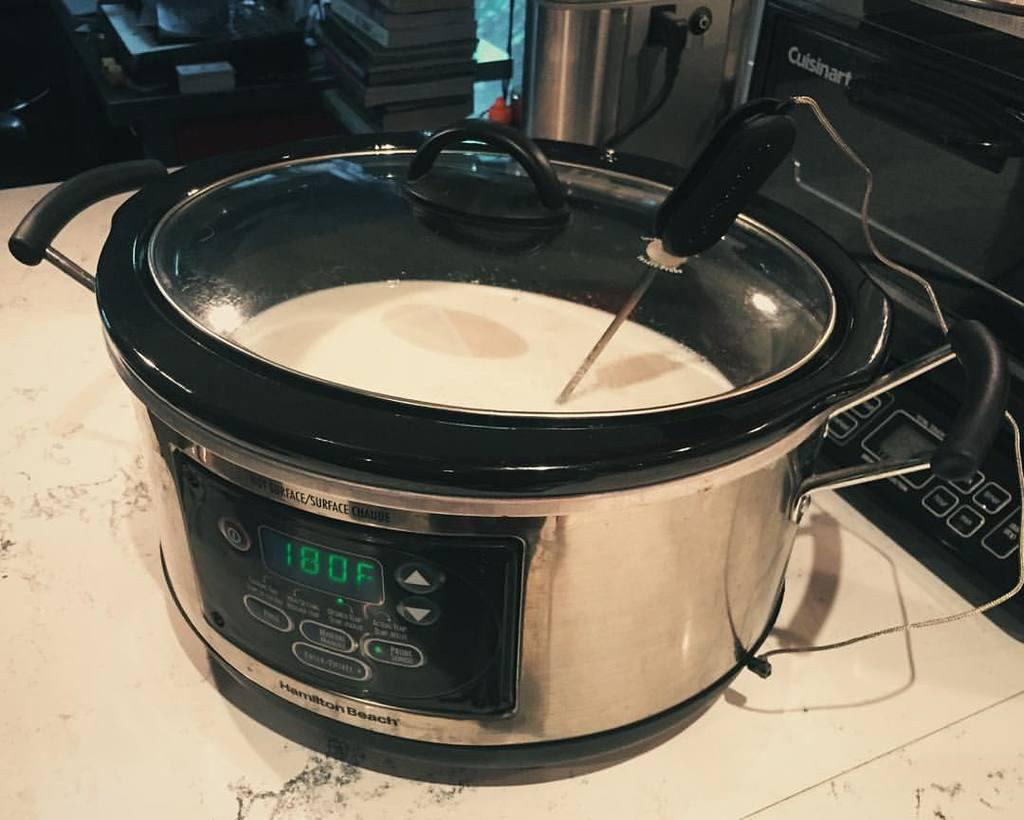Provide a one-sentence caption for the provided image. pressure cooker set to 180 degrees with soup in it. 